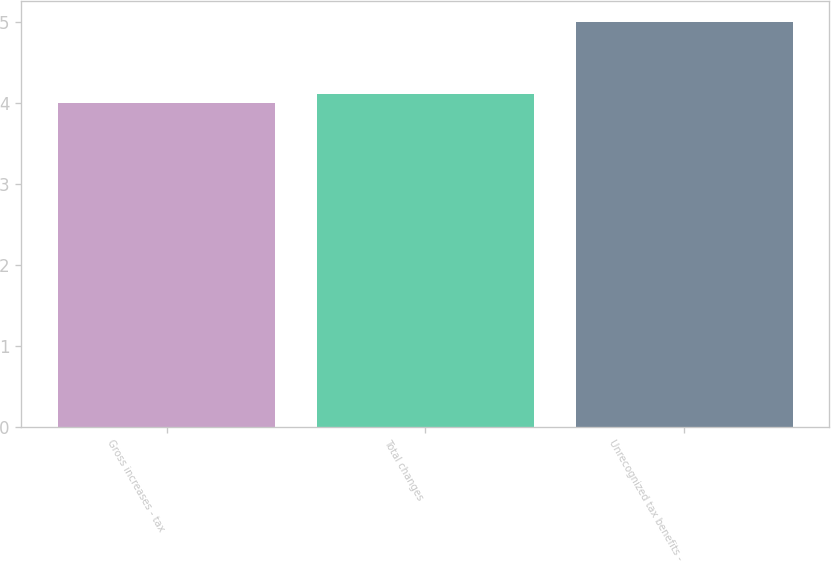<chart> <loc_0><loc_0><loc_500><loc_500><bar_chart><fcel>Gross increases - tax<fcel>Total changes<fcel>Unrecognized tax benefits -<nl><fcel>4<fcel>4.1<fcel>5<nl></chart> 